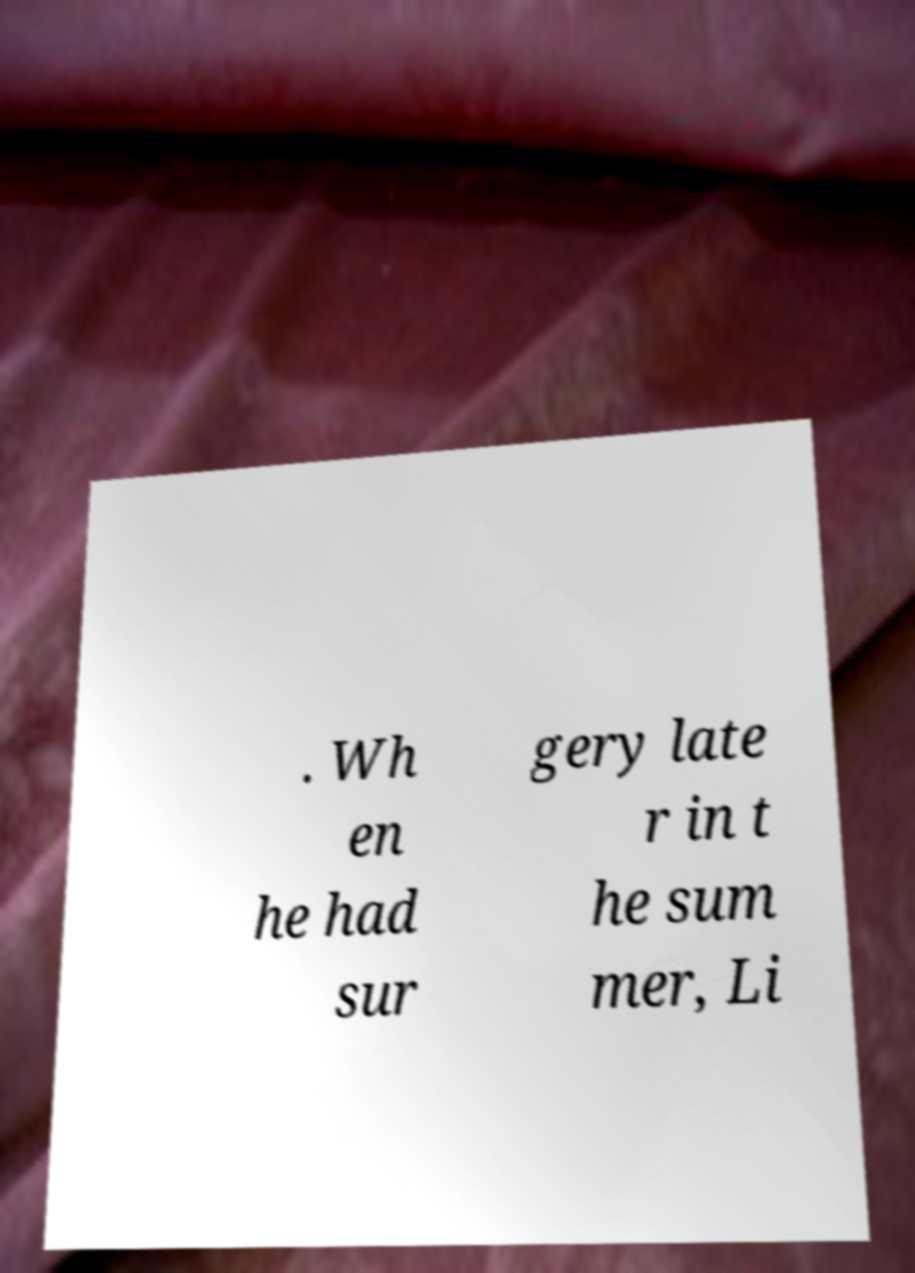For documentation purposes, I need the text within this image transcribed. Could you provide that? . Wh en he had sur gery late r in t he sum mer, Li 